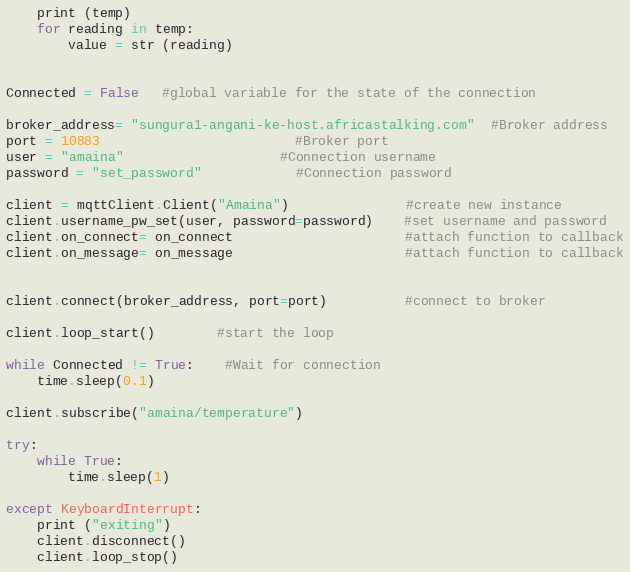Convert code to text. <code><loc_0><loc_0><loc_500><loc_500><_Python_>    print (temp)
    for reading in temp:
        value = str (reading)
    
   
Connected = False   #global variable for the state of the connection
 
broker_address= "sungura1-angani-ke-host.africastalking.com"  #Broker address
port = 10883                         #Broker port
user = "amaina"                    #Connection username
password = "set_password"            #Connection password
 
client = mqttClient.Client("Amaina")               #create new instance
client.username_pw_set(user, password=password)    #set username and password
client.on_connect= on_connect                      #attach function to callback
client.on_message= on_message                      #attach function to callback


client.connect(broker_address, port=port)          #connect to broker
 
client.loop_start()        #start the loop
 
while Connected != True:    #Wait for connection
    time.sleep(0.1)
 
client.subscribe("amaina/temperature")
 
try:
    while True:
        time.sleep(1)
 
except KeyboardInterrupt:
    print ("exiting")
    client.disconnect()
    client.loop_stop()
</code> 